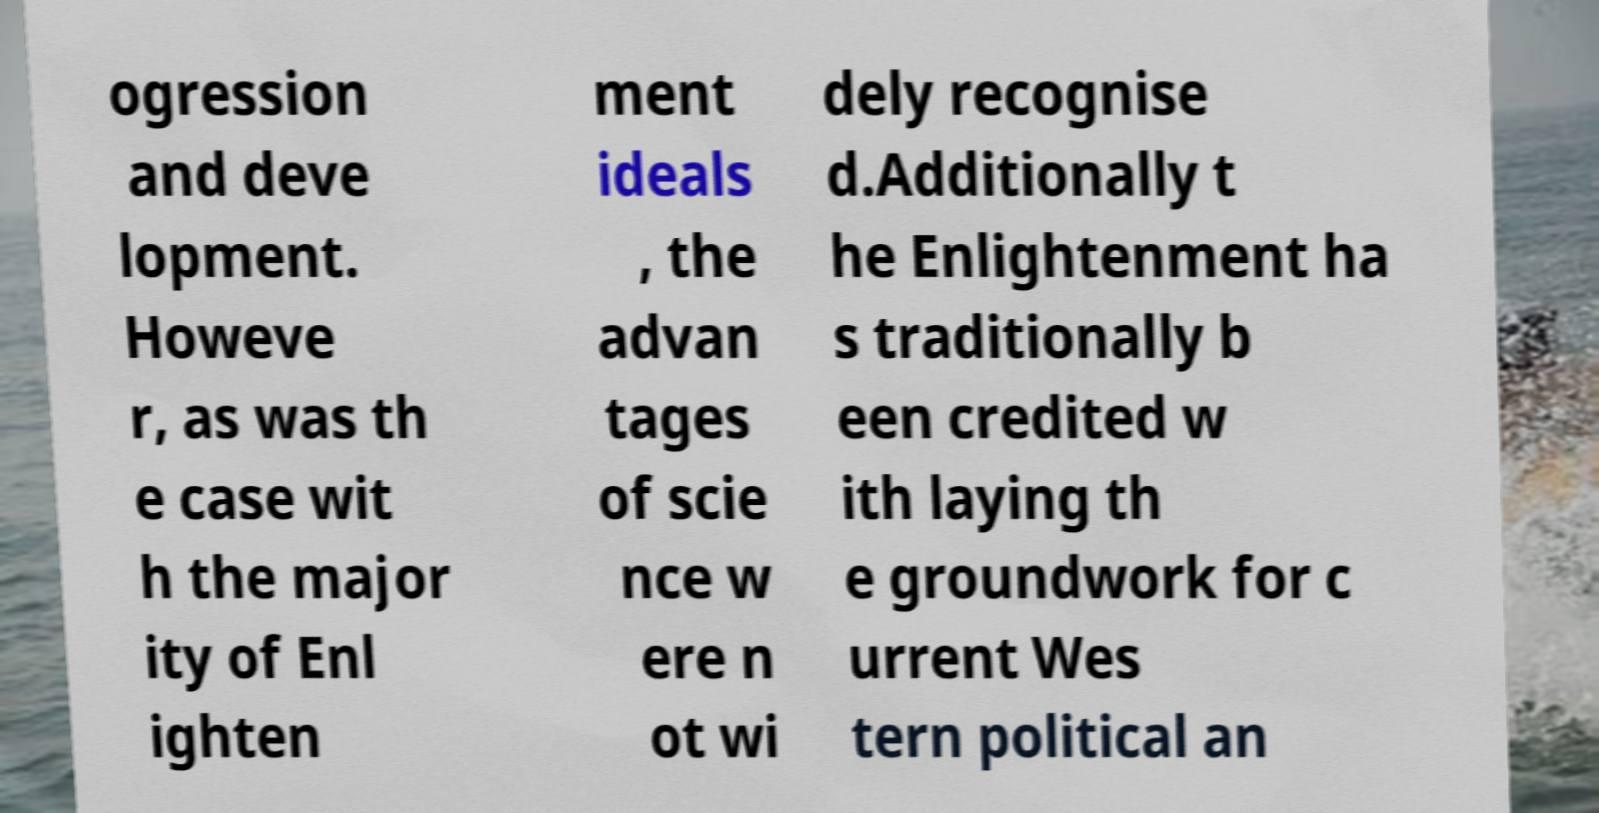For documentation purposes, I need the text within this image transcribed. Could you provide that? ogression and deve lopment. Howeve r, as was th e case wit h the major ity of Enl ighten ment ideals , the advan tages of scie nce w ere n ot wi dely recognise d.Additionally t he Enlightenment ha s traditionally b een credited w ith laying th e groundwork for c urrent Wes tern political an 